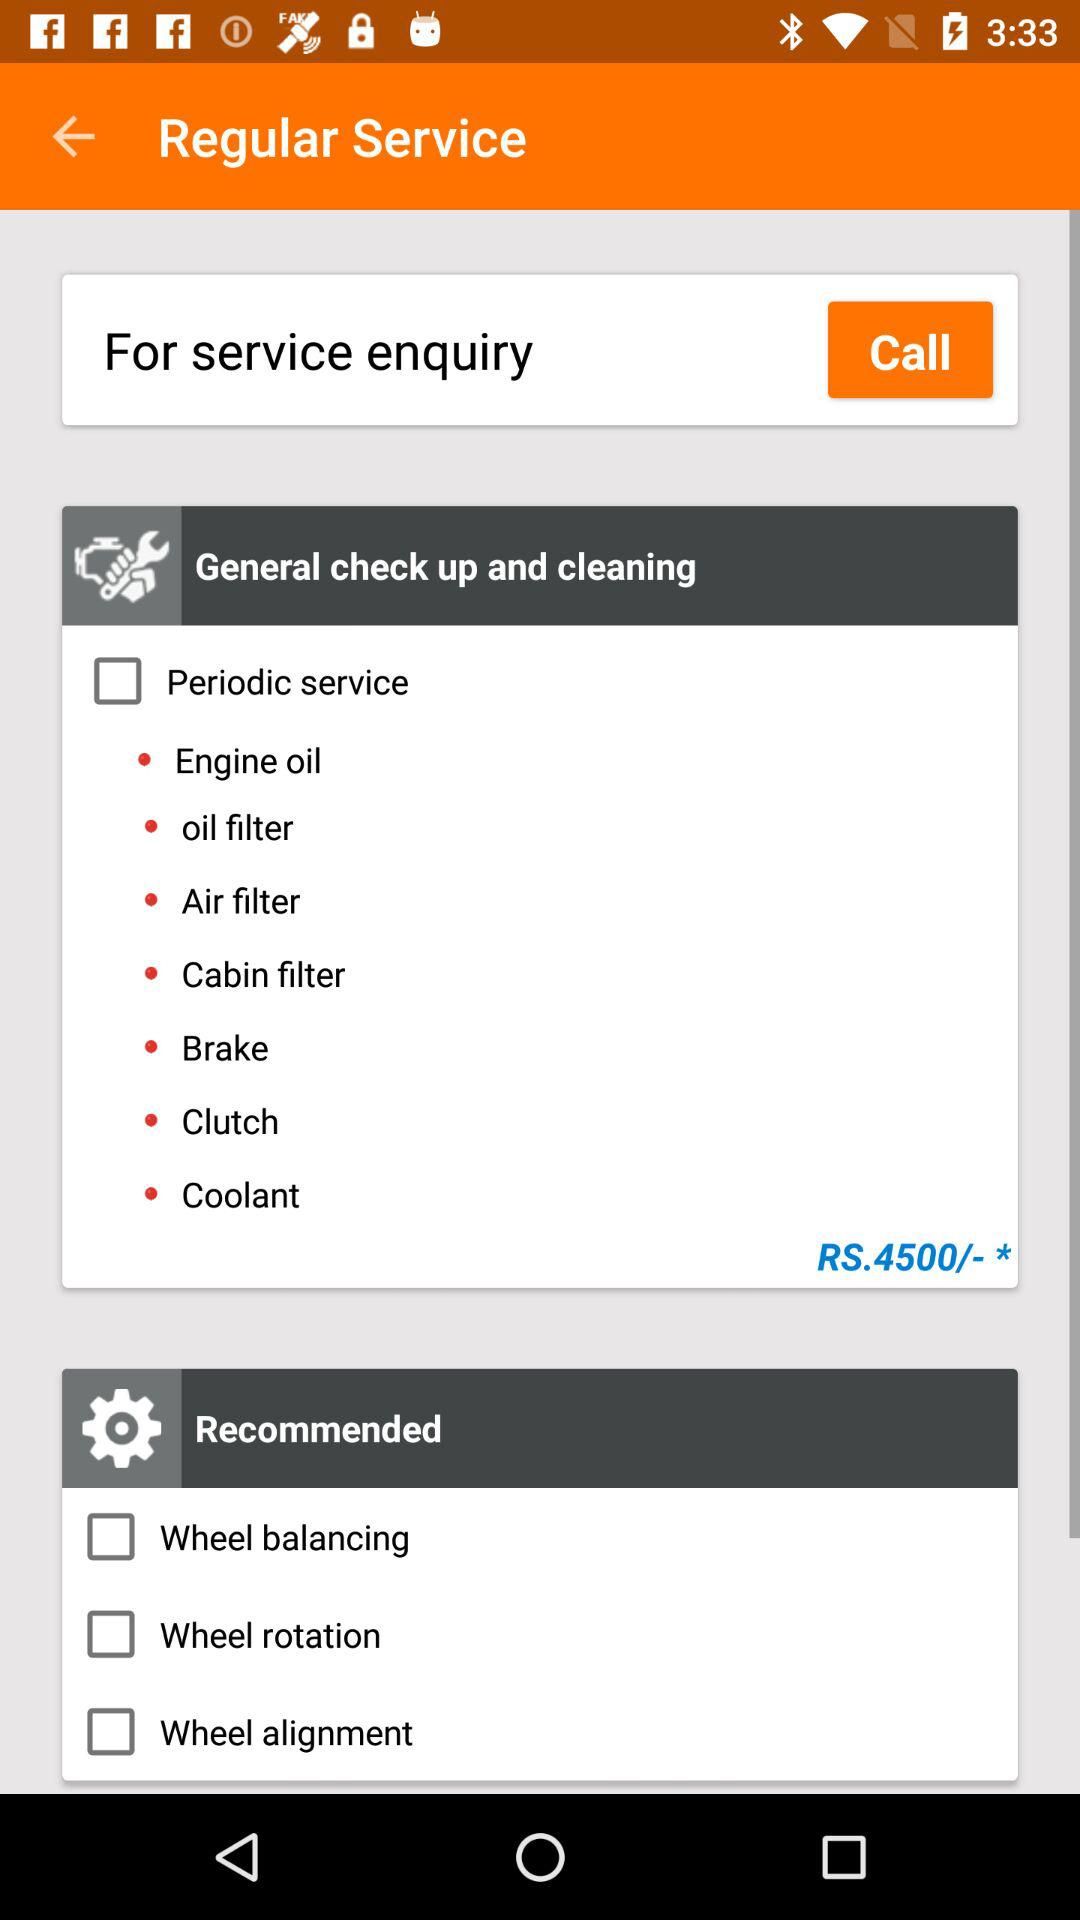What is the amount? The amount is Rs.4500/- *. 